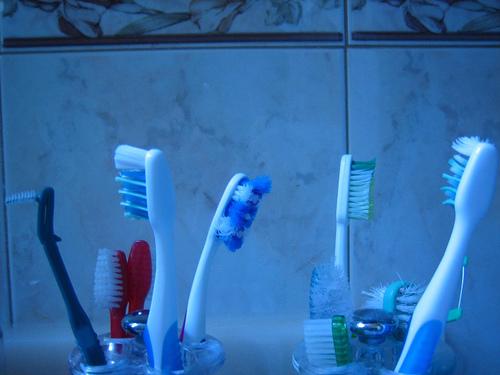Do some of the brushes need to be replaced?
Short answer required. Yes. How man pink toothbrushes are in the container?
Give a very brief answer. 0. What is on the toothbrush?
Quick response, please. Nothing. Is this a large family?
Write a very short answer. Yes. How many similar brushes are in the image?
Give a very brief answer. 4. Would you be disgusted to use the blue toothbrush?
Answer briefly. Yes. 